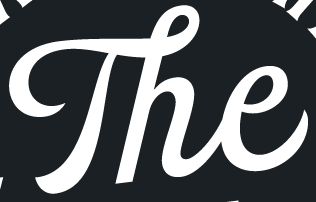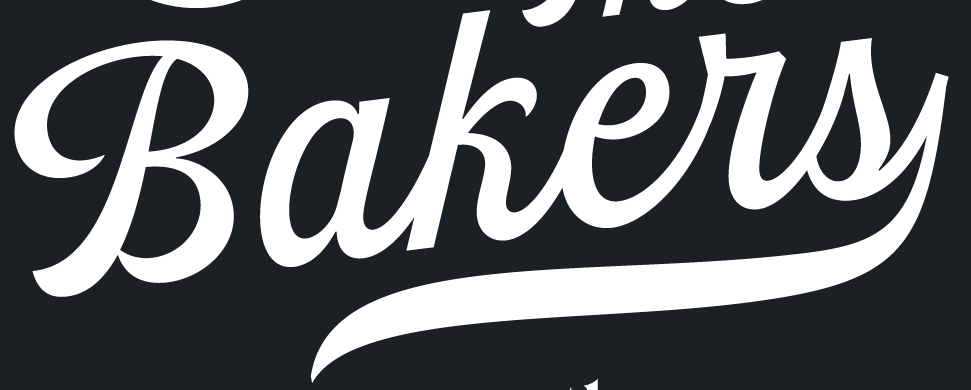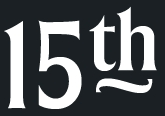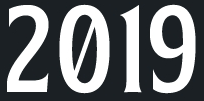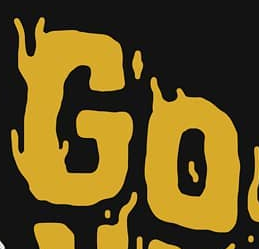Read the text from these images in sequence, separated by a semicolon. The; Bakers; 15th; 2019; GO 